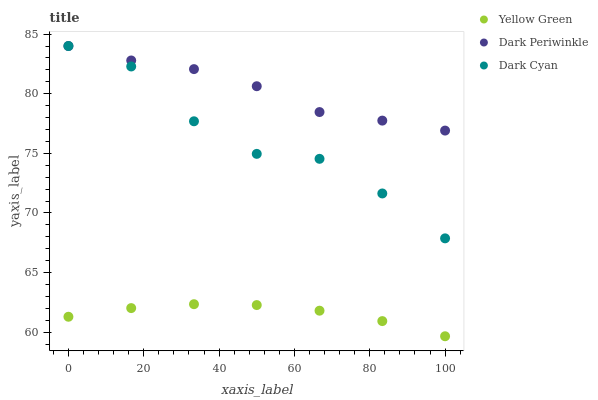Does Yellow Green have the minimum area under the curve?
Answer yes or no. Yes. Does Dark Periwinkle have the maximum area under the curve?
Answer yes or no. Yes. Does Dark Periwinkle have the minimum area under the curve?
Answer yes or no. No. Does Yellow Green have the maximum area under the curve?
Answer yes or no. No. Is Yellow Green the smoothest?
Answer yes or no. Yes. Is Dark Cyan the roughest?
Answer yes or no. Yes. Is Dark Periwinkle the smoothest?
Answer yes or no. No. Is Dark Periwinkle the roughest?
Answer yes or no. No. Does Yellow Green have the lowest value?
Answer yes or no. Yes. Does Dark Periwinkle have the lowest value?
Answer yes or no. No. Does Dark Periwinkle have the highest value?
Answer yes or no. Yes. Does Yellow Green have the highest value?
Answer yes or no. No. Is Yellow Green less than Dark Periwinkle?
Answer yes or no. Yes. Is Dark Periwinkle greater than Yellow Green?
Answer yes or no. Yes. Does Dark Periwinkle intersect Dark Cyan?
Answer yes or no. Yes. Is Dark Periwinkle less than Dark Cyan?
Answer yes or no. No. Is Dark Periwinkle greater than Dark Cyan?
Answer yes or no. No. Does Yellow Green intersect Dark Periwinkle?
Answer yes or no. No. 